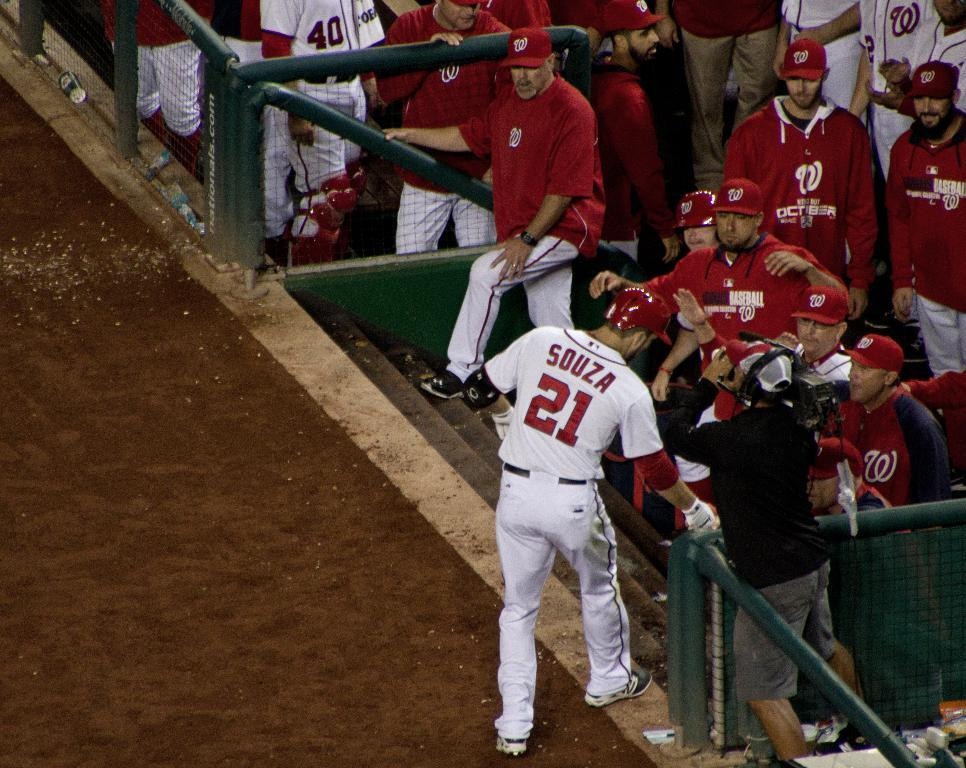<image>
Create a compact narrative representing the image presented. A baseball player wearing white and with the name Souza and number 21 on his back talks to members of the opposing team who are all dressed in red. 